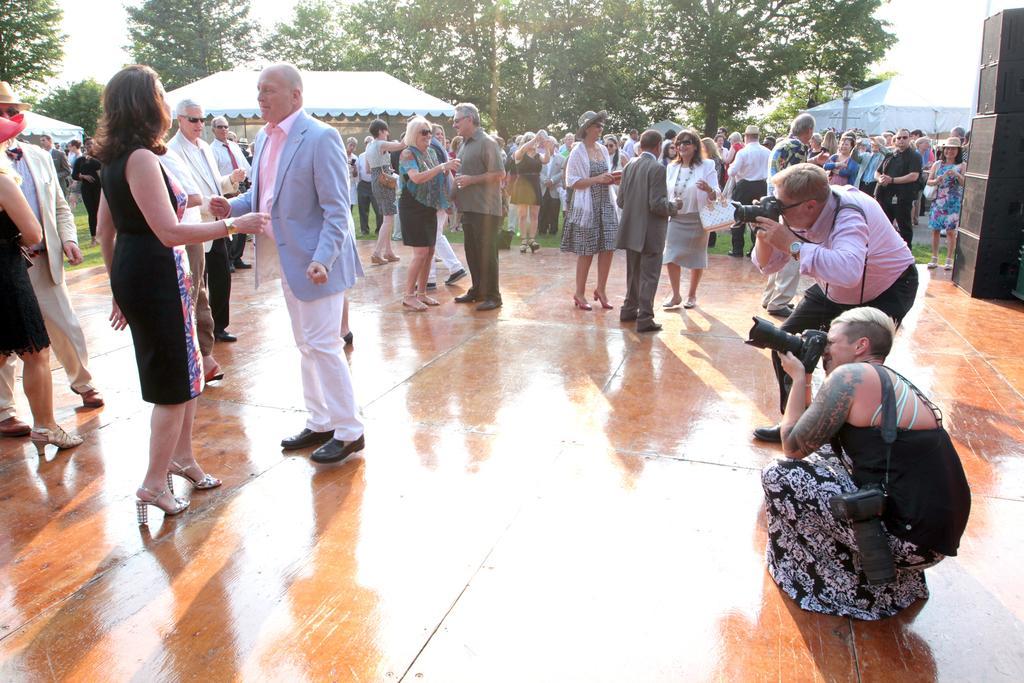Please provide a concise description of this image. In this image we can see a group of persons. Behind the persons we can see a group of trees and tents. At the top we can see the sky. On the right side, we can see speakers and two persons taking photos. 